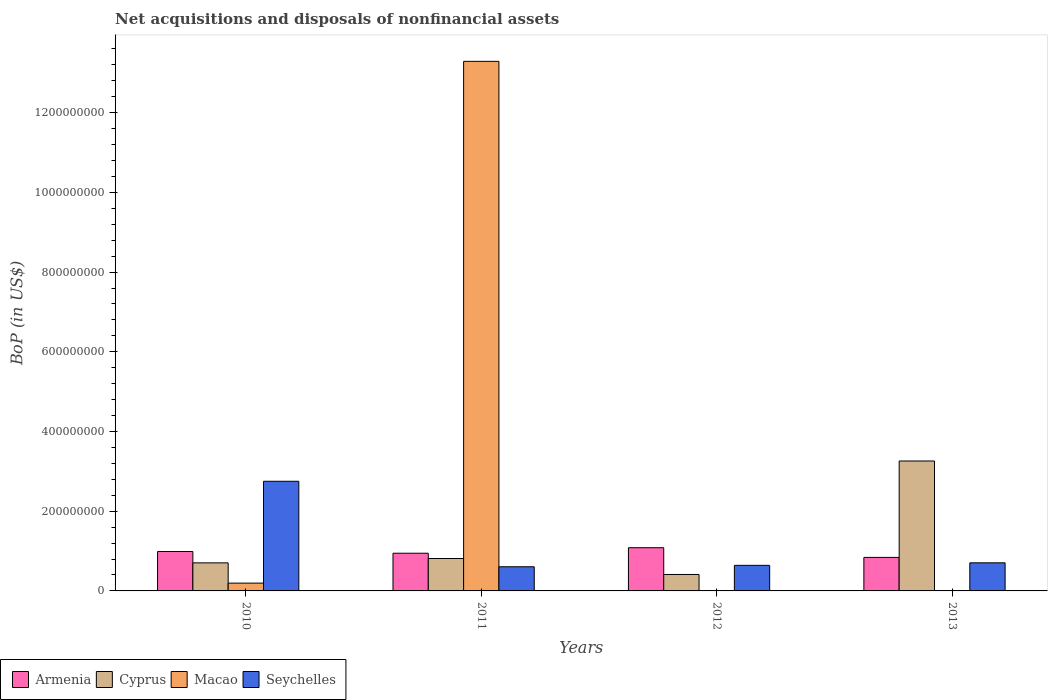Are the number of bars on each tick of the X-axis equal?
Ensure brevity in your answer.  No. What is the Balance of Payments in Seychelles in 2011?
Your response must be concise. 6.06e+07. Across all years, what is the maximum Balance of Payments in Cyprus?
Your response must be concise. 3.26e+08. Across all years, what is the minimum Balance of Payments in Macao?
Offer a terse response. 0. What is the total Balance of Payments in Macao in the graph?
Provide a short and direct response. 1.35e+09. What is the difference between the Balance of Payments in Armenia in 2010 and that in 2012?
Your answer should be compact. -9.55e+06. What is the difference between the Balance of Payments in Armenia in 2010 and the Balance of Payments in Macao in 2012?
Ensure brevity in your answer.  9.89e+07. What is the average Balance of Payments in Armenia per year?
Provide a short and direct response. 9.65e+07. In the year 2013, what is the difference between the Balance of Payments in Seychelles and Balance of Payments in Armenia?
Your answer should be very brief. -1.36e+07. In how many years, is the Balance of Payments in Cyprus greater than 920000000 US$?
Keep it short and to the point. 0. What is the ratio of the Balance of Payments in Armenia in 2011 to that in 2012?
Offer a very short reply. 0.87. Is the Balance of Payments in Cyprus in 2012 less than that in 2013?
Provide a succinct answer. Yes. Is the difference between the Balance of Payments in Seychelles in 2012 and 2013 greater than the difference between the Balance of Payments in Armenia in 2012 and 2013?
Give a very brief answer. No. What is the difference between the highest and the second highest Balance of Payments in Seychelles?
Give a very brief answer. 2.05e+08. What is the difference between the highest and the lowest Balance of Payments in Macao?
Ensure brevity in your answer.  1.33e+09. Is the sum of the Balance of Payments in Seychelles in 2012 and 2013 greater than the maximum Balance of Payments in Macao across all years?
Offer a terse response. No. Is it the case that in every year, the sum of the Balance of Payments in Macao and Balance of Payments in Cyprus is greater than the sum of Balance of Payments in Seychelles and Balance of Payments in Armenia?
Provide a succinct answer. No. What is the difference between two consecutive major ticks on the Y-axis?
Keep it short and to the point. 2.00e+08. Where does the legend appear in the graph?
Ensure brevity in your answer.  Bottom left. How many legend labels are there?
Your answer should be compact. 4. What is the title of the graph?
Keep it short and to the point. Net acquisitions and disposals of nonfinancial assets. Does "Nepal" appear as one of the legend labels in the graph?
Your answer should be very brief. No. What is the label or title of the Y-axis?
Your response must be concise. BoP (in US$). What is the BoP (in US$) of Armenia in 2010?
Keep it short and to the point. 9.89e+07. What is the BoP (in US$) of Cyprus in 2010?
Provide a short and direct response. 7.04e+07. What is the BoP (in US$) in Macao in 2010?
Provide a succinct answer. 1.96e+07. What is the BoP (in US$) in Seychelles in 2010?
Give a very brief answer. 2.75e+08. What is the BoP (in US$) in Armenia in 2011?
Offer a very short reply. 9.46e+07. What is the BoP (in US$) in Cyprus in 2011?
Provide a short and direct response. 8.13e+07. What is the BoP (in US$) in Macao in 2011?
Your response must be concise. 1.33e+09. What is the BoP (in US$) of Seychelles in 2011?
Keep it short and to the point. 6.06e+07. What is the BoP (in US$) in Armenia in 2012?
Make the answer very short. 1.08e+08. What is the BoP (in US$) in Cyprus in 2012?
Offer a very short reply. 4.13e+07. What is the BoP (in US$) of Seychelles in 2012?
Your answer should be compact. 6.42e+07. What is the BoP (in US$) of Armenia in 2013?
Your response must be concise. 8.41e+07. What is the BoP (in US$) of Cyprus in 2013?
Provide a succinct answer. 3.26e+08. What is the BoP (in US$) in Macao in 2013?
Your answer should be very brief. 0. What is the BoP (in US$) in Seychelles in 2013?
Offer a terse response. 7.05e+07. Across all years, what is the maximum BoP (in US$) in Armenia?
Ensure brevity in your answer.  1.08e+08. Across all years, what is the maximum BoP (in US$) of Cyprus?
Keep it short and to the point. 3.26e+08. Across all years, what is the maximum BoP (in US$) in Macao?
Give a very brief answer. 1.33e+09. Across all years, what is the maximum BoP (in US$) of Seychelles?
Provide a short and direct response. 2.75e+08. Across all years, what is the minimum BoP (in US$) of Armenia?
Make the answer very short. 8.41e+07. Across all years, what is the minimum BoP (in US$) of Cyprus?
Ensure brevity in your answer.  4.13e+07. Across all years, what is the minimum BoP (in US$) of Macao?
Offer a very short reply. 0. Across all years, what is the minimum BoP (in US$) of Seychelles?
Offer a very short reply. 6.06e+07. What is the total BoP (in US$) in Armenia in the graph?
Offer a terse response. 3.86e+08. What is the total BoP (in US$) of Cyprus in the graph?
Your answer should be very brief. 5.19e+08. What is the total BoP (in US$) in Macao in the graph?
Provide a succinct answer. 1.35e+09. What is the total BoP (in US$) in Seychelles in the graph?
Ensure brevity in your answer.  4.70e+08. What is the difference between the BoP (in US$) of Armenia in 2010 and that in 2011?
Ensure brevity in your answer.  4.26e+06. What is the difference between the BoP (in US$) of Cyprus in 2010 and that in 2011?
Your answer should be compact. -1.09e+07. What is the difference between the BoP (in US$) of Macao in 2010 and that in 2011?
Offer a terse response. -1.31e+09. What is the difference between the BoP (in US$) of Seychelles in 2010 and that in 2011?
Provide a succinct answer. 2.14e+08. What is the difference between the BoP (in US$) in Armenia in 2010 and that in 2012?
Your answer should be very brief. -9.55e+06. What is the difference between the BoP (in US$) of Cyprus in 2010 and that in 2012?
Provide a succinct answer. 2.91e+07. What is the difference between the BoP (in US$) of Seychelles in 2010 and that in 2012?
Provide a short and direct response. 2.11e+08. What is the difference between the BoP (in US$) of Armenia in 2010 and that in 2013?
Ensure brevity in your answer.  1.47e+07. What is the difference between the BoP (in US$) in Cyprus in 2010 and that in 2013?
Offer a very short reply. -2.56e+08. What is the difference between the BoP (in US$) in Seychelles in 2010 and that in 2013?
Your response must be concise. 2.05e+08. What is the difference between the BoP (in US$) in Armenia in 2011 and that in 2012?
Provide a short and direct response. -1.38e+07. What is the difference between the BoP (in US$) of Cyprus in 2011 and that in 2012?
Keep it short and to the point. 4.01e+07. What is the difference between the BoP (in US$) in Seychelles in 2011 and that in 2012?
Keep it short and to the point. -3.52e+06. What is the difference between the BoP (in US$) in Armenia in 2011 and that in 2013?
Your answer should be very brief. 1.05e+07. What is the difference between the BoP (in US$) of Cyprus in 2011 and that in 2013?
Ensure brevity in your answer.  -2.45e+08. What is the difference between the BoP (in US$) in Seychelles in 2011 and that in 2013?
Your response must be concise. -9.86e+06. What is the difference between the BoP (in US$) in Armenia in 2012 and that in 2013?
Your answer should be very brief. 2.43e+07. What is the difference between the BoP (in US$) in Cyprus in 2012 and that in 2013?
Make the answer very short. -2.85e+08. What is the difference between the BoP (in US$) of Seychelles in 2012 and that in 2013?
Provide a short and direct response. -6.34e+06. What is the difference between the BoP (in US$) of Armenia in 2010 and the BoP (in US$) of Cyprus in 2011?
Provide a succinct answer. 1.75e+07. What is the difference between the BoP (in US$) in Armenia in 2010 and the BoP (in US$) in Macao in 2011?
Provide a succinct answer. -1.23e+09. What is the difference between the BoP (in US$) in Armenia in 2010 and the BoP (in US$) in Seychelles in 2011?
Provide a short and direct response. 3.82e+07. What is the difference between the BoP (in US$) of Cyprus in 2010 and the BoP (in US$) of Macao in 2011?
Offer a very short reply. -1.26e+09. What is the difference between the BoP (in US$) of Cyprus in 2010 and the BoP (in US$) of Seychelles in 2011?
Offer a terse response. 9.77e+06. What is the difference between the BoP (in US$) of Macao in 2010 and the BoP (in US$) of Seychelles in 2011?
Ensure brevity in your answer.  -4.10e+07. What is the difference between the BoP (in US$) in Armenia in 2010 and the BoP (in US$) in Cyprus in 2012?
Your answer should be compact. 5.76e+07. What is the difference between the BoP (in US$) of Armenia in 2010 and the BoP (in US$) of Seychelles in 2012?
Ensure brevity in your answer.  3.47e+07. What is the difference between the BoP (in US$) of Cyprus in 2010 and the BoP (in US$) of Seychelles in 2012?
Provide a short and direct response. 6.25e+06. What is the difference between the BoP (in US$) of Macao in 2010 and the BoP (in US$) of Seychelles in 2012?
Make the answer very short. -4.46e+07. What is the difference between the BoP (in US$) of Armenia in 2010 and the BoP (in US$) of Cyprus in 2013?
Offer a very short reply. -2.27e+08. What is the difference between the BoP (in US$) in Armenia in 2010 and the BoP (in US$) in Seychelles in 2013?
Your answer should be compact. 2.84e+07. What is the difference between the BoP (in US$) of Cyprus in 2010 and the BoP (in US$) of Seychelles in 2013?
Your response must be concise. -9.35e+04. What is the difference between the BoP (in US$) of Macao in 2010 and the BoP (in US$) of Seychelles in 2013?
Offer a terse response. -5.09e+07. What is the difference between the BoP (in US$) of Armenia in 2011 and the BoP (in US$) of Cyprus in 2012?
Your answer should be compact. 5.33e+07. What is the difference between the BoP (in US$) in Armenia in 2011 and the BoP (in US$) in Seychelles in 2012?
Your response must be concise. 3.04e+07. What is the difference between the BoP (in US$) in Cyprus in 2011 and the BoP (in US$) in Seychelles in 2012?
Provide a succinct answer. 1.72e+07. What is the difference between the BoP (in US$) of Macao in 2011 and the BoP (in US$) of Seychelles in 2012?
Offer a very short reply. 1.26e+09. What is the difference between the BoP (in US$) of Armenia in 2011 and the BoP (in US$) of Cyprus in 2013?
Offer a terse response. -2.31e+08. What is the difference between the BoP (in US$) of Armenia in 2011 and the BoP (in US$) of Seychelles in 2013?
Provide a short and direct response. 2.41e+07. What is the difference between the BoP (in US$) in Cyprus in 2011 and the BoP (in US$) in Seychelles in 2013?
Provide a succinct answer. 1.08e+07. What is the difference between the BoP (in US$) in Macao in 2011 and the BoP (in US$) in Seychelles in 2013?
Keep it short and to the point. 1.26e+09. What is the difference between the BoP (in US$) in Armenia in 2012 and the BoP (in US$) in Cyprus in 2013?
Ensure brevity in your answer.  -2.18e+08. What is the difference between the BoP (in US$) of Armenia in 2012 and the BoP (in US$) of Seychelles in 2013?
Offer a terse response. 3.79e+07. What is the difference between the BoP (in US$) of Cyprus in 2012 and the BoP (in US$) of Seychelles in 2013?
Your answer should be very brief. -2.92e+07. What is the average BoP (in US$) in Armenia per year?
Ensure brevity in your answer.  9.65e+07. What is the average BoP (in US$) in Cyprus per year?
Give a very brief answer. 1.30e+08. What is the average BoP (in US$) in Macao per year?
Offer a terse response. 3.37e+08. What is the average BoP (in US$) of Seychelles per year?
Keep it short and to the point. 1.18e+08. In the year 2010, what is the difference between the BoP (in US$) of Armenia and BoP (in US$) of Cyprus?
Ensure brevity in your answer.  2.84e+07. In the year 2010, what is the difference between the BoP (in US$) in Armenia and BoP (in US$) in Macao?
Provide a short and direct response. 7.93e+07. In the year 2010, what is the difference between the BoP (in US$) in Armenia and BoP (in US$) in Seychelles?
Your response must be concise. -1.76e+08. In the year 2010, what is the difference between the BoP (in US$) in Cyprus and BoP (in US$) in Macao?
Ensure brevity in your answer.  5.08e+07. In the year 2010, what is the difference between the BoP (in US$) in Cyprus and BoP (in US$) in Seychelles?
Give a very brief answer. -2.05e+08. In the year 2010, what is the difference between the BoP (in US$) in Macao and BoP (in US$) in Seychelles?
Make the answer very short. -2.56e+08. In the year 2011, what is the difference between the BoP (in US$) of Armenia and BoP (in US$) of Cyprus?
Offer a terse response. 1.33e+07. In the year 2011, what is the difference between the BoP (in US$) of Armenia and BoP (in US$) of Macao?
Provide a succinct answer. -1.23e+09. In the year 2011, what is the difference between the BoP (in US$) in Armenia and BoP (in US$) in Seychelles?
Your answer should be very brief. 3.40e+07. In the year 2011, what is the difference between the BoP (in US$) of Cyprus and BoP (in US$) of Macao?
Your answer should be very brief. -1.25e+09. In the year 2011, what is the difference between the BoP (in US$) of Cyprus and BoP (in US$) of Seychelles?
Offer a terse response. 2.07e+07. In the year 2011, what is the difference between the BoP (in US$) of Macao and BoP (in US$) of Seychelles?
Your answer should be very brief. 1.27e+09. In the year 2012, what is the difference between the BoP (in US$) of Armenia and BoP (in US$) of Cyprus?
Give a very brief answer. 6.71e+07. In the year 2012, what is the difference between the BoP (in US$) in Armenia and BoP (in US$) in Seychelles?
Your response must be concise. 4.43e+07. In the year 2012, what is the difference between the BoP (in US$) of Cyprus and BoP (in US$) of Seychelles?
Keep it short and to the point. -2.29e+07. In the year 2013, what is the difference between the BoP (in US$) in Armenia and BoP (in US$) in Cyprus?
Keep it short and to the point. -2.42e+08. In the year 2013, what is the difference between the BoP (in US$) in Armenia and BoP (in US$) in Seychelles?
Your answer should be compact. 1.36e+07. In the year 2013, what is the difference between the BoP (in US$) of Cyprus and BoP (in US$) of Seychelles?
Keep it short and to the point. 2.56e+08. What is the ratio of the BoP (in US$) in Armenia in 2010 to that in 2011?
Your answer should be very brief. 1.04. What is the ratio of the BoP (in US$) of Cyprus in 2010 to that in 2011?
Keep it short and to the point. 0.87. What is the ratio of the BoP (in US$) in Macao in 2010 to that in 2011?
Your answer should be compact. 0.01. What is the ratio of the BoP (in US$) of Seychelles in 2010 to that in 2011?
Make the answer very short. 4.54. What is the ratio of the BoP (in US$) in Armenia in 2010 to that in 2012?
Your response must be concise. 0.91. What is the ratio of the BoP (in US$) of Cyprus in 2010 to that in 2012?
Your answer should be very brief. 1.71. What is the ratio of the BoP (in US$) of Seychelles in 2010 to that in 2012?
Make the answer very short. 4.29. What is the ratio of the BoP (in US$) of Armenia in 2010 to that in 2013?
Provide a succinct answer. 1.18. What is the ratio of the BoP (in US$) of Cyprus in 2010 to that in 2013?
Give a very brief answer. 0.22. What is the ratio of the BoP (in US$) of Seychelles in 2010 to that in 2013?
Your response must be concise. 3.9. What is the ratio of the BoP (in US$) in Armenia in 2011 to that in 2012?
Offer a terse response. 0.87. What is the ratio of the BoP (in US$) of Cyprus in 2011 to that in 2012?
Give a very brief answer. 1.97. What is the ratio of the BoP (in US$) of Seychelles in 2011 to that in 2012?
Your answer should be compact. 0.95. What is the ratio of the BoP (in US$) of Armenia in 2011 to that in 2013?
Ensure brevity in your answer.  1.12. What is the ratio of the BoP (in US$) in Cyprus in 2011 to that in 2013?
Ensure brevity in your answer.  0.25. What is the ratio of the BoP (in US$) in Seychelles in 2011 to that in 2013?
Make the answer very short. 0.86. What is the ratio of the BoP (in US$) in Armenia in 2012 to that in 2013?
Your response must be concise. 1.29. What is the ratio of the BoP (in US$) in Cyprus in 2012 to that in 2013?
Your answer should be compact. 0.13. What is the ratio of the BoP (in US$) of Seychelles in 2012 to that in 2013?
Provide a succinct answer. 0.91. What is the difference between the highest and the second highest BoP (in US$) in Armenia?
Make the answer very short. 9.55e+06. What is the difference between the highest and the second highest BoP (in US$) in Cyprus?
Your answer should be very brief. 2.45e+08. What is the difference between the highest and the second highest BoP (in US$) of Seychelles?
Provide a short and direct response. 2.05e+08. What is the difference between the highest and the lowest BoP (in US$) of Armenia?
Give a very brief answer. 2.43e+07. What is the difference between the highest and the lowest BoP (in US$) in Cyprus?
Make the answer very short. 2.85e+08. What is the difference between the highest and the lowest BoP (in US$) in Macao?
Keep it short and to the point. 1.33e+09. What is the difference between the highest and the lowest BoP (in US$) in Seychelles?
Your response must be concise. 2.14e+08. 